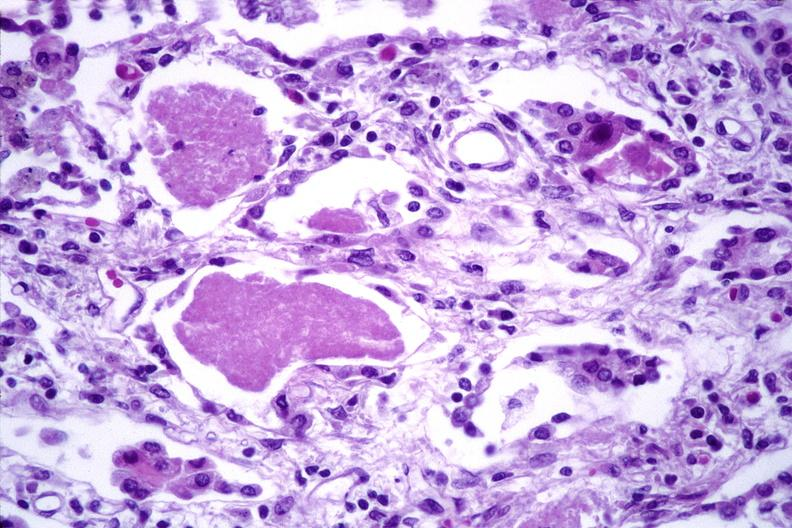what is present?
Answer the question using a single word or phrase. Respiratory 